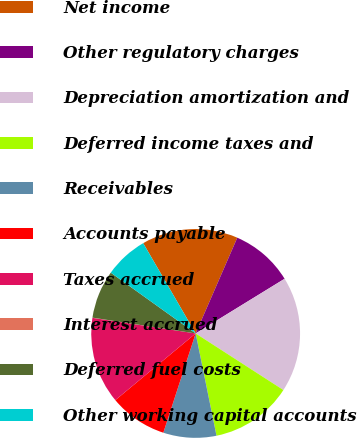<chart> <loc_0><loc_0><loc_500><loc_500><pie_chart><fcel>Net income<fcel>Other regulatory charges<fcel>Depreciation amortization and<fcel>Deferred income taxes and<fcel>Receivables<fcel>Accounts payable<fcel>Taxes accrued<fcel>Interest accrued<fcel>Deferred fuel costs<fcel>Other working capital accounts<nl><fcel>14.91%<fcel>9.7%<fcel>17.89%<fcel>12.68%<fcel>8.21%<fcel>8.96%<fcel>13.42%<fcel>0.03%<fcel>7.47%<fcel>6.73%<nl></chart> 